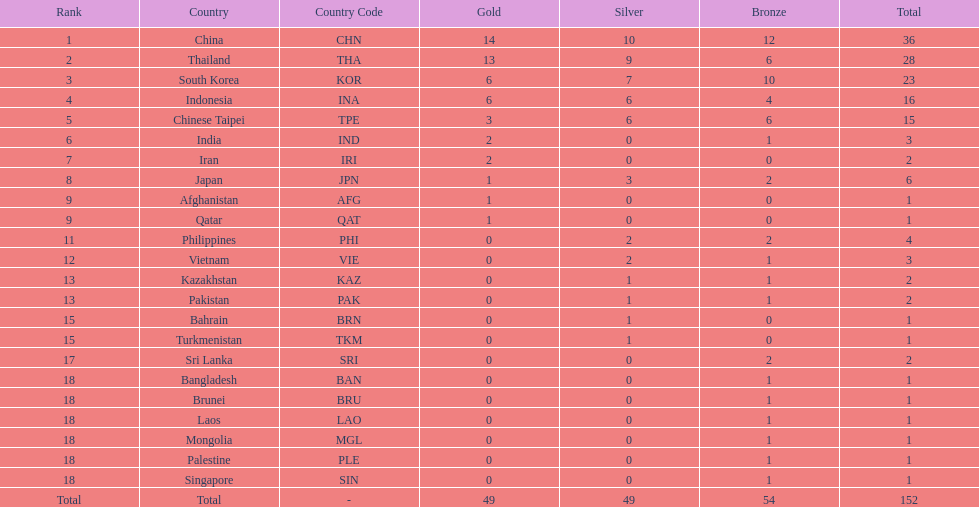Did the philippines or kazakhstan have a higher number of total medals? Philippines. 